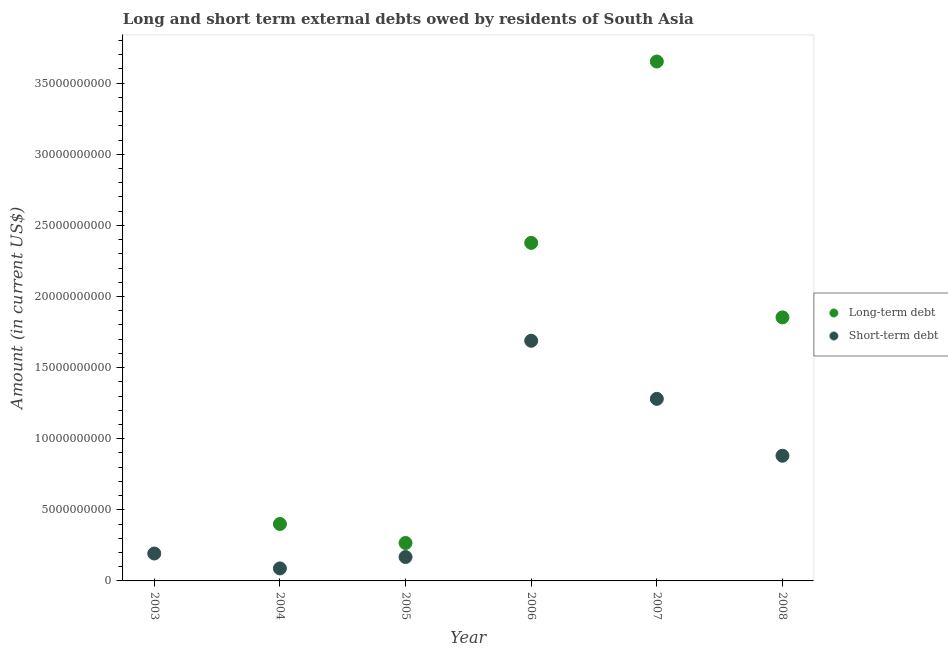What is the long-term debts owed by residents in 2004?
Offer a very short reply. 4.00e+09. Across all years, what is the maximum long-term debts owed by residents?
Your response must be concise. 3.65e+1. Across all years, what is the minimum short-term debts owed by residents?
Make the answer very short. 8.80e+08. In which year was the long-term debts owed by residents maximum?
Your response must be concise. 2007. What is the total short-term debts owed by residents in the graph?
Ensure brevity in your answer.  4.30e+1. What is the difference between the short-term debts owed by residents in 2004 and that in 2006?
Offer a very short reply. -1.60e+1. What is the difference between the short-term debts owed by residents in 2003 and the long-term debts owed by residents in 2008?
Provide a succinct answer. -1.66e+1. What is the average long-term debts owed by residents per year?
Offer a very short reply. 1.42e+1. In the year 2004, what is the difference between the long-term debts owed by residents and short-term debts owed by residents?
Provide a succinct answer. 3.12e+09. What is the ratio of the long-term debts owed by residents in 2005 to that in 2008?
Your response must be concise. 0.14. What is the difference between the highest and the second highest short-term debts owed by residents?
Give a very brief answer. 4.08e+09. What is the difference between the highest and the lowest long-term debts owed by residents?
Your answer should be compact. 3.65e+1. In how many years, is the short-term debts owed by residents greater than the average short-term debts owed by residents taken over all years?
Provide a succinct answer. 3. Is the sum of the long-term debts owed by residents in 2005 and 2006 greater than the maximum short-term debts owed by residents across all years?
Ensure brevity in your answer.  Yes. Is the long-term debts owed by residents strictly less than the short-term debts owed by residents over the years?
Provide a short and direct response. No. How many years are there in the graph?
Your response must be concise. 6. What is the difference between two consecutive major ticks on the Y-axis?
Give a very brief answer. 5.00e+09. Are the values on the major ticks of Y-axis written in scientific E-notation?
Keep it short and to the point. No. Where does the legend appear in the graph?
Offer a very short reply. Center right. How many legend labels are there?
Give a very brief answer. 2. How are the legend labels stacked?
Provide a succinct answer. Vertical. What is the title of the graph?
Give a very brief answer. Long and short term external debts owed by residents of South Asia. Does "Resident workers" appear as one of the legend labels in the graph?
Your response must be concise. No. What is the Amount (in current US$) of Long-term debt in 2003?
Your answer should be compact. 0. What is the Amount (in current US$) in Short-term debt in 2003?
Provide a succinct answer. 1.93e+09. What is the Amount (in current US$) in Long-term debt in 2004?
Your answer should be very brief. 4.00e+09. What is the Amount (in current US$) in Short-term debt in 2004?
Provide a short and direct response. 8.80e+08. What is the Amount (in current US$) in Long-term debt in 2005?
Offer a terse response. 2.67e+09. What is the Amount (in current US$) of Short-term debt in 2005?
Your response must be concise. 1.68e+09. What is the Amount (in current US$) of Long-term debt in 2006?
Keep it short and to the point. 2.38e+1. What is the Amount (in current US$) of Short-term debt in 2006?
Your answer should be very brief. 1.69e+1. What is the Amount (in current US$) in Long-term debt in 2007?
Make the answer very short. 3.65e+1. What is the Amount (in current US$) in Short-term debt in 2007?
Offer a terse response. 1.28e+1. What is the Amount (in current US$) in Long-term debt in 2008?
Offer a terse response. 1.85e+1. What is the Amount (in current US$) in Short-term debt in 2008?
Keep it short and to the point. 8.80e+09. Across all years, what is the maximum Amount (in current US$) in Long-term debt?
Keep it short and to the point. 3.65e+1. Across all years, what is the maximum Amount (in current US$) of Short-term debt?
Provide a short and direct response. 1.69e+1. Across all years, what is the minimum Amount (in current US$) of Short-term debt?
Your response must be concise. 8.80e+08. What is the total Amount (in current US$) in Long-term debt in the graph?
Offer a very short reply. 8.55e+1. What is the total Amount (in current US$) in Short-term debt in the graph?
Your answer should be compact. 4.30e+1. What is the difference between the Amount (in current US$) of Short-term debt in 2003 and that in 2004?
Ensure brevity in your answer.  1.05e+09. What is the difference between the Amount (in current US$) in Short-term debt in 2003 and that in 2005?
Ensure brevity in your answer.  2.47e+08. What is the difference between the Amount (in current US$) of Short-term debt in 2003 and that in 2006?
Keep it short and to the point. -1.50e+1. What is the difference between the Amount (in current US$) in Short-term debt in 2003 and that in 2007?
Your response must be concise. -1.09e+1. What is the difference between the Amount (in current US$) in Short-term debt in 2003 and that in 2008?
Ensure brevity in your answer.  -6.87e+09. What is the difference between the Amount (in current US$) in Long-term debt in 2004 and that in 2005?
Keep it short and to the point. 1.34e+09. What is the difference between the Amount (in current US$) in Short-term debt in 2004 and that in 2005?
Offer a very short reply. -8.02e+08. What is the difference between the Amount (in current US$) in Long-term debt in 2004 and that in 2006?
Offer a terse response. -1.98e+1. What is the difference between the Amount (in current US$) in Short-term debt in 2004 and that in 2006?
Keep it short and to the point. -1.60e+1. What is the difference between the Amount (in current US$) of Long-term debt in 2004 and that in 2007?
Offer a very short reply. -3.25e+1. What is the difference between the Amount (in current US$) of Short-term debt in 2004 and that in 2007?
Your response must be concise. -1.19e+1. What is the difference between the Amount (in current US$) in Long-term debt in 2004 and that in 2008?
Give a very brief answer. -1.45e+1. What is the difference between the Amount (in current US$) in Short-term debt in 2004 and that in 2008?
Offer a terse response. -7.92e+09. What is the difference between the Amount (in current US$) in Long-term debt in 2005 and that in 2006?
Your response must be concise. -2.11e+1. What is the difference between the Amount (in current US$) of Short-term debt in 2005 and that in 2006?
Your answer should be compact. -1.52e+1. What is the difference between the Amount (in current US$) of Long-term debt in 2005 and that in 2007?
Keep it short and to the point. -3.39e+1. What is the difference between the Amount (in current US$) in Short-term debt in 2005 and that in 2007?
Make the answer very short. -1.11e+1. What is the difference between the Amount (in current US$) in Long-term debt in 2005 and that in 2008?
Your answer should be compact. -1.59e+1. What is the difference between the Amount (in current US$) of Short-term debt in 2005 and that in 2008?
Your answer should be very brief. -7.12e+09. What is the difference between the Amount (in current US$) in Long-term debt in 2006 and that in 2007?
Ensure brevity in your answer.  -1.28e+1. What is the difference between the Amount (in current US$) in Short-term debt in 2006 and that in 2007?
Keep it short and to the point. 4.08e+09. What is the difference between the Amount (in current US$) of Long-term debt in 2006 and that in 2008?
Your response must be concise. 5.24e+09. What is the difference between the Amount (in current US$) in Short-term debt in 2006 and that in 2008?
Provide a succinct answer. 8.08e+09. What is the difference between the Amount (in current US$) in Long-term debt in 2007 and that in 2008?
Your answer should be compact. 1.80e+1. What is the difference between the Amount (in current US$) of Short-term debt in 2007 and that in 2008?
Give a very brief answer. 4.00e+09. What is the difference between the Amount (in current US$) in Long-term debt in 2004 and the Amount (in current US$) in Short-term debt in 2005?
Ensure brevity in your answer.  2.32e+09. What is the difference between the Amount (in current US$) of Long-term debt in 2004 and the Amount (in current US$) of Short-term debt in 2006?
Provide a succinct answer. -1.29e+1. What is the difference between the Amount (in current US$) of Long-term debt in 2004 and the Amount (in current US$) of Short-term debt in 2007?
Your answer should be compact. -8.80e+09. What is the difference between the Amount (in current US$) of Long-term debt in 2004 and the Amount (in current US$) of Short-term debt in 2008?
Ensure brevity in your answer.  -4.80e+09. What is the difference between the Amount (in current US$) of Long-term debt in 2005 and the Amount (in current US$) of Short-term debt in 2006?
Ensure brevity in your answer.  -1.42e+1. What is the difference between the Amount (in current US$) in Long-term debt in 2005 and the Amount (in current US$) in Short-term debt in 2007?
Keep it short and to the point. -1.01e+1. What is the difference between the Amount (in current US$) in Long-term debt in 2005 and the Amount (in current US$) in Short-term debt in 2008?
Keep it short and to the point. -6.13e+09. What is the difference between the Amount (in current US$) of Long-term debt in 2006 and the Amount (in current US$) of Short-term debt in 2007?
Provide a short and direct response. 1.10e+1. What is the difference between the Amount (in current US$) in Long-term debt in 2006 and the Amount (in current US$) in Short-term debt in 2008?
Ensure brevity in your answer.  1.50e+1. What is the difference between the Amount (in current US$) of Long-term debt in 2007 and the Amount (in current US$) of Short-term debt in 2008?
Provide a succinct answer. 2.77e+1. What is the average Amount (in current US$) in Long-term debt per year?
Offer a very short reply. 1.42e+1. What is the average Amount (in current US$) in Short-term debt per year?
Offer a very short reply. 7.16e+09. In the year 2004, what is the difference between the Amount (in current US$) of Long-term debt and Amount (in current US$) of Short-term debt?
Provide a succinct answer. 3.12e+09. In the year 2005, what is the difference between the Amount (in current US$) in Long-term debt and Amount (in current US$) in Short-term debt?
Your answer should be very brief. 9.86e+08. In the year 2006, what is the difference between the Amount (in current US$) in Long-term debt and Amount (in current US$) in Short-term debt?
Give a very brief answer. 6.88e+09. In the year 2007, what is the difference between the Amount (in current US$) in Long-term debt and Amount (in current US$) in Short-term debt?
Provide a succinct answer. 2.37e+1. In the year 2008, what is the difference between the Amount (in current US$) in Long-term debt and Amount (in current US$) in Short-term debt?
Make the answer very short. 9.73e+09. What is the ratio of the Amount (in current US$) in Short-term debt in 2003 to that in 2004?
Your answer should be compact. 2.19. What is the ratio of the Amount (in current US$) in Short-term debt in 2003 to that in 2005?
Offer a terse response. 1.15. What is the ratio of the Amount (in current US$) in Short-term debt in 2003 to that in 2006?
Give a very brief answer. 0.11. What is the ratio of the Amount (in current US$) of Short-term debt in 2003 to that in 2007?
Give a very brief answer. 0.15. What is the ratio of the Amount (in current US$) in Short-term debt in 2003 to that in 2008?
Your response must be concise. 0.22. What is the ratio of the Amount (in current US$) of Long-term debt in 2004 to that in 2005?
Give a very brief answer. 1.5. What is the ratio of the Amount (in current US$) of Short-term debt in 2004 to that in 2005?
Offer a terse response. 0.52. What is the ratio of the Amount (in current US$) of Long-term debt in 2004 to that in 2006?
Make the answer very short. 0.17. What is the ratio of the Amount (in current US$) of Short-term debt in 2004 to that in 2006?
Offer a very short reply. 0.05. What is the ratio of the Amount (in current US$) in Long-term debt in 2004 to that in 2007?
Offer a very short reply. 0.11. What is the ratio of the Amount (in current US$) of Short-term debt in 2004 to that in 2007?
Your answer should be compact. 0.07. What is the ratio of the Amount (in current US$) in Long-term debt in 2004 to that in 2008?
Provide a succinct answer. 0.22. What is the ratio of the Amount (in current US$) in Short-term debt in 2004 to that in 2008?
Your answer should be very brief. 0.1. What is the ratio of the Amount (in current US$) in Long-term debt in 2005 to that in 2006?
Ensure brevity in your answer.  0.11. What is the ratio of the Amount (in current US$) in Short-term debt in 2005 to that in 2006?
Offer a terse response. 0.1. What is the ratio of the Amount (in current US$) of Long-term debt in 2005 to that in 2007?
Offer a very short reply. 0.07. What is the ratio of the Amount (in current US$) in Short-term debt in 2005 to that in 2007?
Provide a short and direct response. 0.13. What is the ratio of the Amount (in current US$) in Long-term debt in 2005 to that in 2008?
Your answer should be very brief. 0.14. What is the ratio of the Amount (in current US$) of Short-term debt in 2005 to that in 2008?
Provide a succinct answer. 0.19. What is the ratio of the Amount (in current US$) in Long-term debt in 2006 to that in 2007?
Keep it short and to the point. 0.65. What is the ratio of the Amount (in current US$) of Short-term debt in 2006 to that in 2007?
Your answer should be very brief. 1.32. What is the ratio of the Amount (in current US$) in Long-term debt in 2006 to that in 2008?
Offer a very short reply. 1.28. What is the ratio of the Amount (in current US$) in Short-term debt in 2006 to that in 2008?
Make the answer very short. 1.92. What is the ratio of the Amount (in current US$) in Long-term debt in 2007 to that in 2008?
Offer a terse response. 1.97. What is the ratio of the Amount (in current US$) of Short-term debt in 2007 to that in 2008?
Keep it short and to the point. 1.45. What is the difference between the highest and the second highest Amount (in current US$) in Long-term debt?
Your answer should be compact. 1.28e+1. What is the difference between the highest and the second highest Amount (in current US$) in Short-term debt?
Your answer should be compact. 4.08e+09. What is the difference between the highest and the lowest Amount (in current US$) in Long-term debt?
Provide a succinct answer. 3.65e+1. What is the difference between the highest and the lowest Amount (in current US$) of Short-term debt?
Make the answer very short. 1.60e+1. 